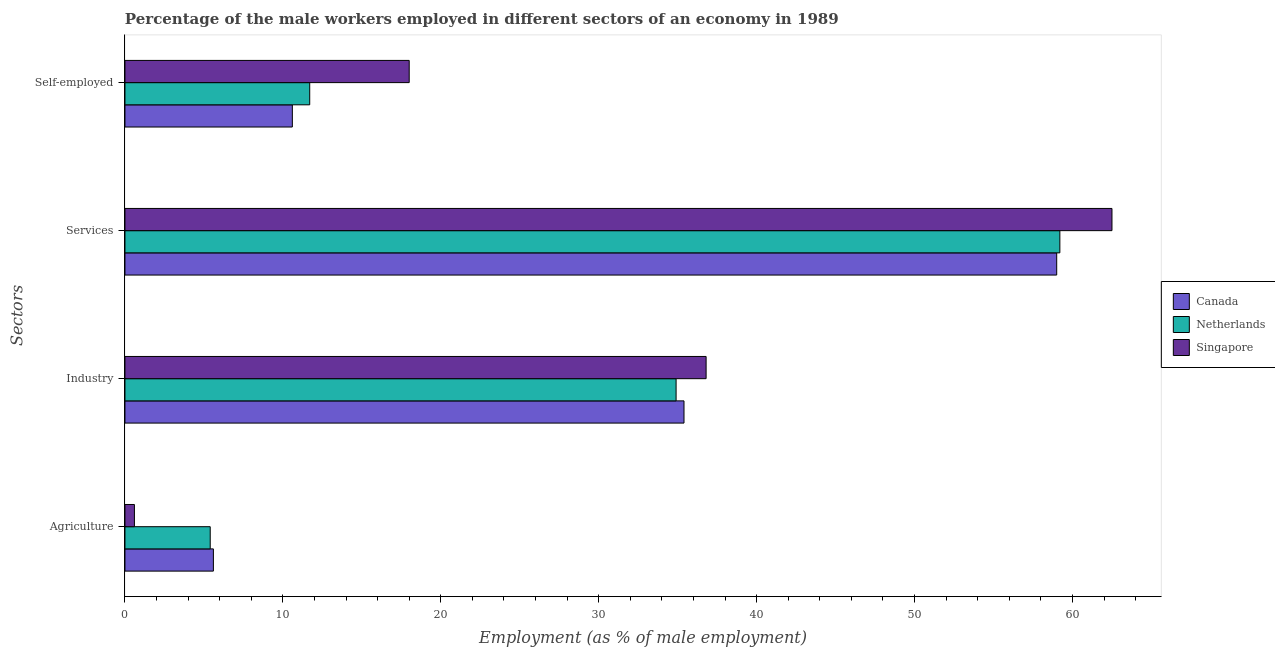How many different coloured bars are there?
Offer a terse response. 3. Are the number of bars per tick equal to the number of legend labels?
Offer a very short reply. Yes. How many bars are there on the 1st tick from the top?
Offer a very short reply. 3. How many bars are there on the 1st tick from the bottom?
Ensure brevity in your answer.  3. What is the label of the 2nd group of bars from the top?
Make the answer very short. Services. What is the percentage of male workers in industry in Singapore?
Your answer should be compact. 36.8. In which country was the percentage of self employed male workers maximum?
Provide a succinct answer. Singapore. What is the total percentage of self employed male workers in the graph?
Keep it short and to the point. 40.3. What is the difference between the percentage of male workers in industry in Singapore and that in Netherlands?
Offer a terse response. 1.9. What is the difference between the percentage of self employed male workers in Singapore and the percentage of male workers in agriculture in Canada?
Your answer should be very brief. 12.4. What is the average percentage of male workers in industry per country?
Provide a succinct answer. 35.7. What is the difference between the percentage of male workers in services and percentage of male workers in industry in Singapore?
Make the answer very short. 25.7. What is the ratio of the percentage of male workers in agriculture in Canada to that in Singapore?
Provide a short and direct response. 9.33. Is the difference between the percentage of self employed male workers in Netherlands and Singapore greater than the difference between the percentage of male workers in services in Netherlands and Singapore?
Offer a very short reply. No. What is the difference between the highest and the second highest percentage of self employed male workers?
Give a very brief answer. 6.3. What is the difference between the highest and the lowest percentage of male workers in agriculture?
Your answer should be very brief. 5. In how many countries, is the percentage of male workers in industry greater than the average percentage of male workers in industry taken over all countries?
Provide a succinct answer. 1. How many countries are there in the graph?
Provide a succinct answer. 3. What is the difference between two consecutive major ticks on the X-axis?
Offer a very short reply. 10. Are the values on the major ticks of X-axis written in scientific E-notation?
Offer a terse response. No. Does the graph contain any zero values?
Ensure brevity in your answer.  No. Does the graph contain grids?
Provide a short and direct response. No. How many legend labels are there?
Make the answer very short. 3. What is the title of the graph?
Make the answer very short. Percentage of the male workers employed in different sectors of an economy in 1989. What is the label or title of the X-axis?
Provide a short and direct response. Employment (as % of male employment). What is the label or title of the Y-axis?
Give a very brief answer. Sectors. What is the Employment (as % of male employment) of Canada in Agriculture?
Your response must be concise. 5.6. What is the Employment (as % of male employment) in Netherlands in Agriculture?
Your answer should be very brief. 5.4. What is the Employment (as % of male employment) in Singapore in Agriculture?
Offer a terse response. 0.6. What is the Employment (as % of male employment) in Canada in Industry?
Offer a very short reply. 35.4. What is the Employment (as % of male employment) in Netherlands in Industry?
Provide a short and direct response. 34.9. What is the Employment (as % of male employment) of Singapore in Industry?
Your response must be concise. 36.8. What is the Employment (as % of male employment) of Netherlands in Services?
Keep it short and to the point. 59.2. What is the Employment (as % of male employment) in Singapore in Services?
Your answer should be compact. 62.5. What is the Employment (as % of male employment) in Canada in Self-employed?
Give a very brief answer. 10.6. What is the Employment (as % of male employment) of Netherlands in Self-employed?
Your answer should be very brief. 11.7. Across all Sectors, what is the maximum Employment (as % of male employment) of Netherlands?
Ensure brevity in your answer.  59.2. Across all Sectors, what is the maximum Employment (as % of male employment) in Singapore?
Make the answer very short. 62.5. Across all Sectors, what is the minimum Employment (as % of male employment) in Canada?
Ensure brevity in your answer.  5.6. Across all Sectors, what is the minimum Employment (as % of male employment) in Netherlands?
Ensure brevity in your answer.  5.4. Across all Sectors, what is the minimum Employment (as % of male employment) in Singapore?
Offer a very short reply. 0.6. What is the total Employment (as % of male employment) in Canada in the graph?
Keep it short and to the point. 110.6. What is the total Employment (as % of male employment) of Netherlands in the graph?
Offer a terse response. 111.2. What is the total Employment (as % of male employment) of Singapore in the graph?
Provide a succinct answer. 117.9. What is the difference between the Employment (as % of male employment) in Canada in Agriculture and that in Industry?
Your response must be concise. -29.8. What is the difference between the Employment (as % of male employment) in Netherlands in Agriculture and that in Industry?
Your answer should be very brief. -29.5. What is the difference between the Employment (as % of male employment) of Singapore in Agriculture and that in Industry?
Keep it short and to the point. -36.2. What is the difference between the Employment (as % of male employment) of Canada in Agriculture and that in Services?
Your answer should be very brief. -53.4. What is the difference between the Employment (as % of male employment) in Netherlands in Agriculture and that in Services?
Your answer should be very brief. -53.8. What is the difference between the Employment (as % of male employment) of Singapore in Agriculture and that in Services?
Ensure brevity in your answer.  -61.9. What is the difference between the Employment (as % of male employment) of Canada in Agriculture and that in Self-employed?
Your answer should be very brief. -5. What is the difference between the Employment (as % of male employment) in Netherlands in Agriculture and that in Self-employed?
Offer a very short reply. -6.3. What is the difference between the Employment (as % of male employment) of Singapore in Agriculture and that in Self-employed?
Your answer should be compact. -17.4. What is the difference between the Employment (as % of male employment) in Canada in Industry and that in Services?
Provide a succinct answer. -23.6. What is the difference between the Employment (as % of male employment) of Netherlands in Industry and that in Services?
Offer a very short reply. -24.3. What is the difference between the Employment (as % of male employment) of Singapore in Industry and that in Services?
Provide a succinct answer. -25.7. What is the difference between the Employment (as % of male employment) in Canada in Industry and that in Self-employed?
Give a very brief answer. 24.8. What is the difference between the Employment (as % of male employment) of Netherlands in Industry and that in Self-employed?
Provide a succinct answer. 23.2. What is the difference between the Employment (as % of male employment) of Singapore in Industry and that in Self-employed?
Offer a very short reply. 18.8. What is the difference between the Employment (as % of male employment) of Canada in Services and that in Self-employed?
Provide a short and direct response. 48.4. What is the difference between the Employment (as % of male employment) in Netherlands in Services and that in Self-employed?
Provide a succinct answer. 47.5. What is the difference between the Employment (as % of male employment) of Singapore in Services and that in Self-employed?
Offer a terse response. 44.5. What is the difference between the Employment (as % of male employment) in Canada in Agriculture and the Employment (as % of male employment) in Netherlands in Industry?
Offer a very short reply. -29.3. What is the difference between the Employment (as % of male employment) of Canada in Agriculture and the Employment (as % of male employment) of Singapore in Industry?
Keep it short and to the point. -31.2. What is the difference between the Employment (as % of male employment) in Netherlands in Agriculture and the Employment (as % of male employment) in Singapore in Industry?
Your answer should be very brief. -31.4. What is the difference between the Employment (as % of male employment) of Canada in Agriculture and the Employment (as % of male employment) of Netherlands in Services?
Make the answer very short. -53.6. What is the difference between the Employment (as % of male employment) of Canada in Agriculture and the Employment (as % of male employment) of Singapore in Services?
Your answer should be compact. -56.9. What is the difference between the Employment (as % of male employment) in Netherlands in Agriculture and the Employment (as % of male employment) in Singapore in Services?
Make the answer very short. -57.1. What is the difference between the Employment (as % of male employment) of Canada in Industry and the Employment (as % of male employment) of Netherlands in Services?
Keep it short and to the point. -23.8. What is the difference between the Employment (as % of male employment) in Canada in Industry and the Employment (as % of male employment) in Singapore in Services?
Ensure brevity in your answer.  -27.1. What is the difference between the Employment (as % of male employment) in Netherlands in Industry and the Employment (as % of male employment) in Singapore in Services?
Your answer should be very brief. -27.6. What is the difference between the Employment (as % of male employment) in Canada in Industry and the Employment (as % of male employment) in Netherlands in Self-employed?
Your answer should be compact. 23.7. What is the difference between the Employment (as % of male employment) in Canada in Industry and the Employment (as % of male employment) in Singapore in Self-employed?
Offer a terse response. 17.4. What is the difference between the Employment (as % of male employment) of Canada in Services and the Employment (as % of male employment) of Netherlands in Self-employed?
Provide a short and direct response. 47.3. What is the difference between the Employment (as % of male employment) of Canada in Services and the Employment (as % of male employment) of Singapore in Self-employed?
Your response must be concise. 41. What is the difference between the Employment (as % of male employment) in Netherlands in Services and the Employment (as % of male employment) in Singapore in Self-employed?
Keep it short and to the point. 41.2. What is the average Employment (as % of male employment) of Canada per Sectors?
Provide a short and direct response. 27.65. What is the average Employment (as % of male employment) of Netherlands per Sectors?
Give a very brief answer. 27.8. What is the average Employment (as % of male employment) in Singapore per Sectors?
Offer a terse response. 29.48. What is the difference between the Employment (as % of male employment) of Canada and Employment (as % of male employment) of Singapore in Agriculture?
Offer a terse response. 5. What is the difference between the Employment (as % of male employment) in Netherlands and Employment (as % of male employment) in Singapore in Agriculture?
Provide a succinct answer. 4.8. What is the difference between the Employment (as % of male employment) of Canada and Employment (as % of male employment) of Netherlands in Industry?
Provide a short and direct response. 0.5. What is the difference between the Employment (as % of male employment) of Canada and Employment (as % of male employment) of Netherlands in Services?
Ensure brevity in your answer.  -0.2. What is the difference between the Employment (as % of male employment) in Netherlands and Employment (as % of male employment) in Singapore in Self-employed?
Provide a succinct answer. -6.3. What is the ratio of the Employment (as % of male employment) in Canada in Agriculture to that in Industry?
Provide a succinct answer. 0.16. What is the ratio of the Employment (as % of male employment) in Netherlands in Agriculture to that in Industry?
Give a very brief answer. 0.15. What is the ratio of the Employment (as % of male employment) in Singapore in Agriculture to that in Industry?
Give a very brief answer. 0.02. What is the ratio of the Employment (as % of male employment) of Canada in Agriculture to that in Services?
Keep it short and to the point. 0.09. What is the ratio of the Employment (as % of male employment) in Netherlands in Agriculture to that in Services?
Your response must be concise. 0.09. What is the ratio of the Employment (as % of male employment) of Singapore in Agriculture to that in Services?
Make the answer very short. 0.01. What is the ratio of the Employment (as % of male employment) of Canada in Agriculture to that in Self-employed?
Keep it short and to the point. 0.53. What is the ratio of the Employment (as % of male employment) of Netherlands in Agriculture to that in Self-employed?
Offer a very short reply. 0.46. What is the ratio of the Employment (as % of male employment) of Singapore in Agriculture to that in Self-employed?
Provide a short and direct response. 0.03. What is the ratio of the Employment (as % of male employment) of Netherlands in Industry to that in Services?
Make the answer very short. 0.59. What is the ratio of the Employment (as % of male employment) of Singapore in Industry to that in Services?
Offer a very short reply. 0.59. What is the ratio of the Employment (as % of male employment) in Canada in Industry to that in Self-employed?
Provide a succinct answer. 3.34. What is the ratio of the Employment (as % of male employment) of Netherlands in Industry to that in Self-employed?
Offer a very short reply. 2.98. What is the ratio of the Employment (as % of male employment) of Singapore in Industry to that in Self-employed?
Make the answer very short. 2.04. What is the ratio of the Employment (as % of male employment) in Canada in Services to that in Self-employed?
Give a very brief answer. 5.57. What is the ratio of the Employment (as % of male employment) in Netherlands in Services to that in Self-employed?
Provide a succinct answer. 5.06. What is the ratio of the Employment (as % of male employment) of Singapore in Services to that in Self-employed?
Your answer should be compact. 3.47. What is the difference between the highest and the second highest Employment (as % of male employment) of Canada?
Give a very brief answer. 23.6. What is the difference between the highest and the second highest Employment (as % of male employment) in Netherlands?
Provide a short and direct response. 24.3. What is the difference between the highest and the second highest Employment (as % of male employment) in Singapore?
Your response must be concise. 25.7. What is the difference between the highest and the lowest Employment (as % of male employment) of Canada?
Your answer should be very brief. 53.4. What is the difference between the highest and the lowest Employment (as % of male employment) of Netherlands?
Your answer should be very brief. 53.8. What is the difference between the highest and the lowest Employment (as % of male employment) of Singapore?
Your response must be concise. 61.9. 